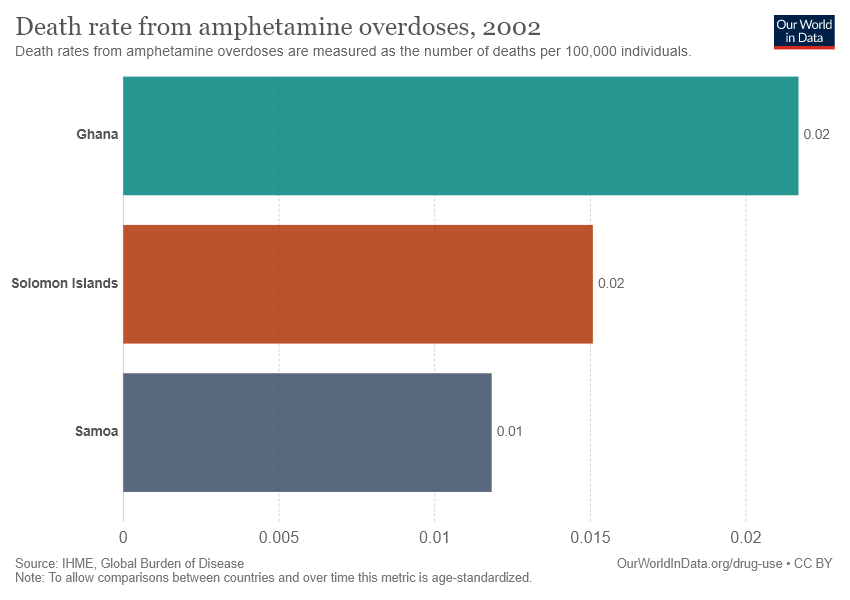Highlight a few significant elements in this photo. According to recent data, Ghana has the highest death rate from amphetamine overdoses out of all countries. The median rate of death among the three countries was 0.01666... 